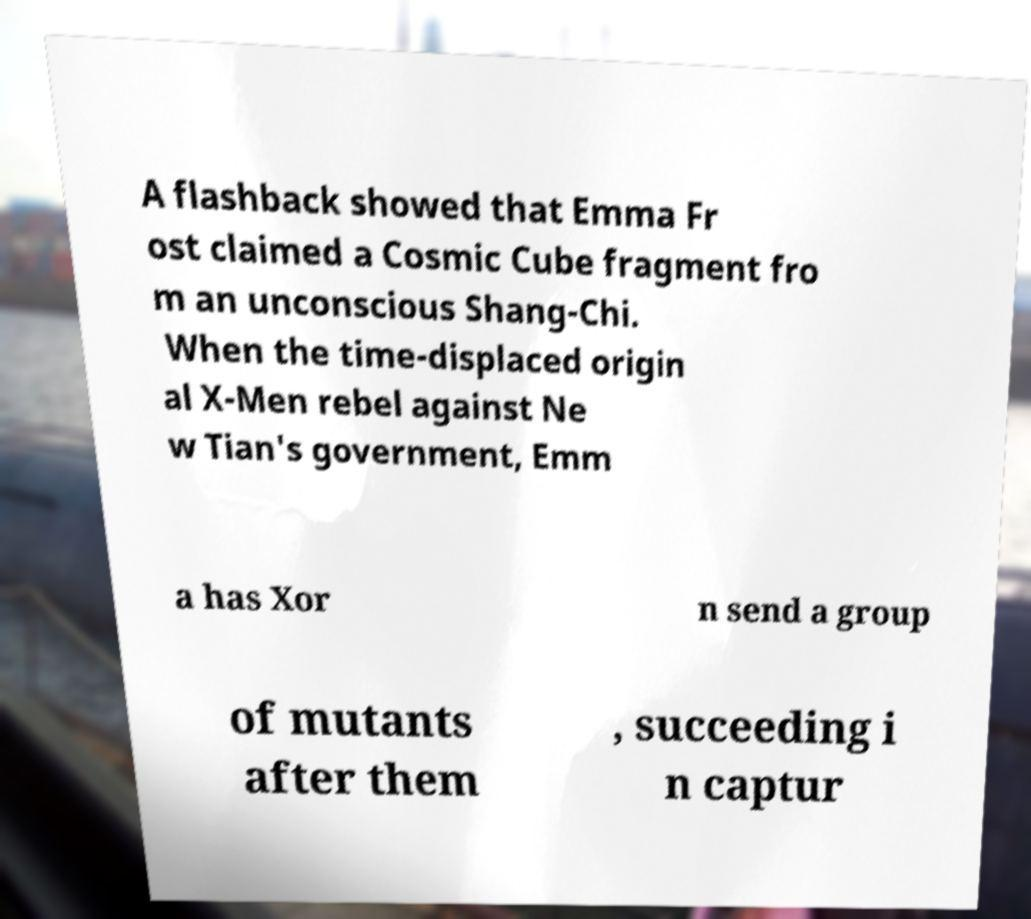What messages or text are displayed in this image? I need them in a readable, typed format. A flashback showed that Emma Fr ost claimed a Cosmic Cube fragment fro m an unconscious Shang-Chi. When the time-displaced origin al X-Men rebel against Ne w Tian's government, Emm a has Xor n send a group of mutants after them , succeeding i n captur 